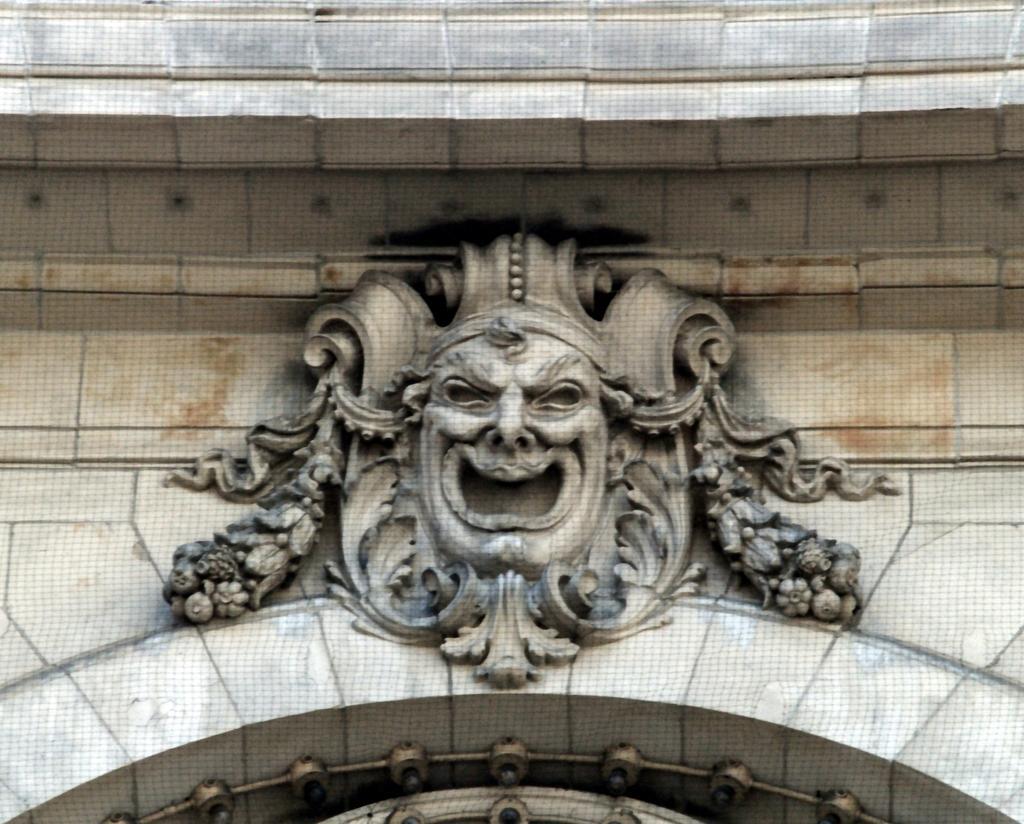Describe this image in one or two sentences. In this picture we can observe carving on the wall. This is in grey color. 